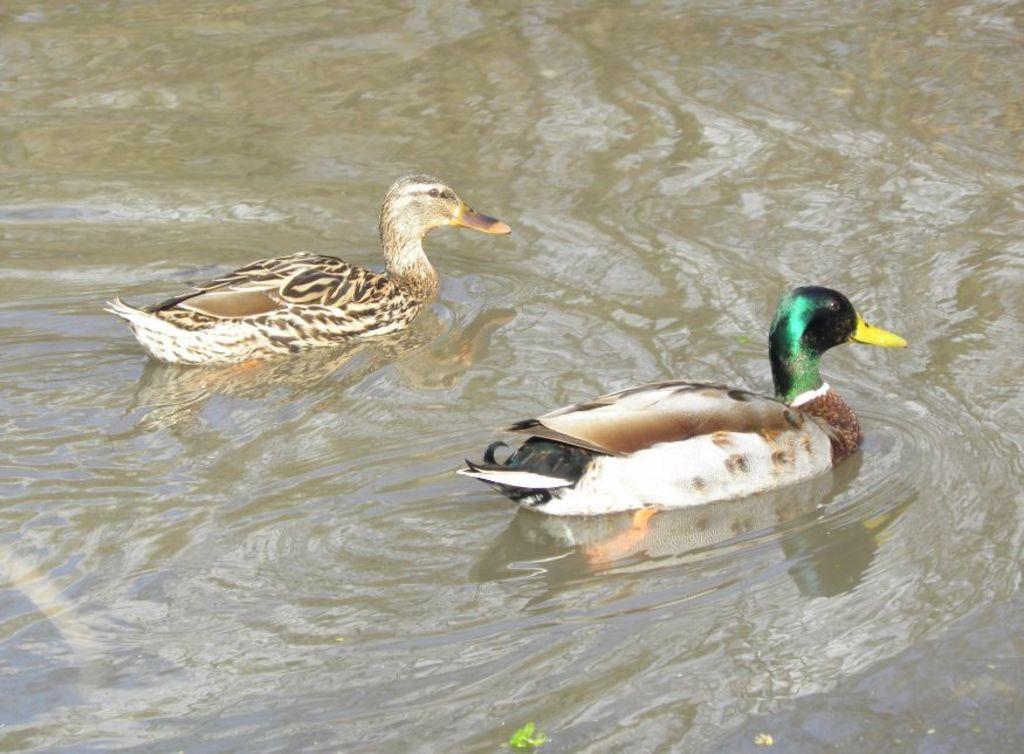Could you give a brief overview of what you see in this image? Here in this picture we can see a couple of ducks present in the water. 